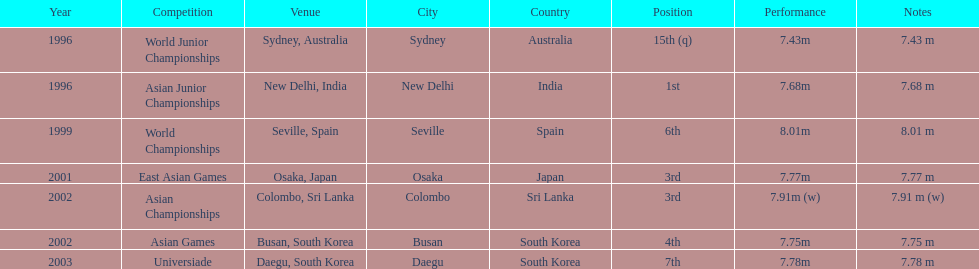How many total competitions were in south korea? 2. 